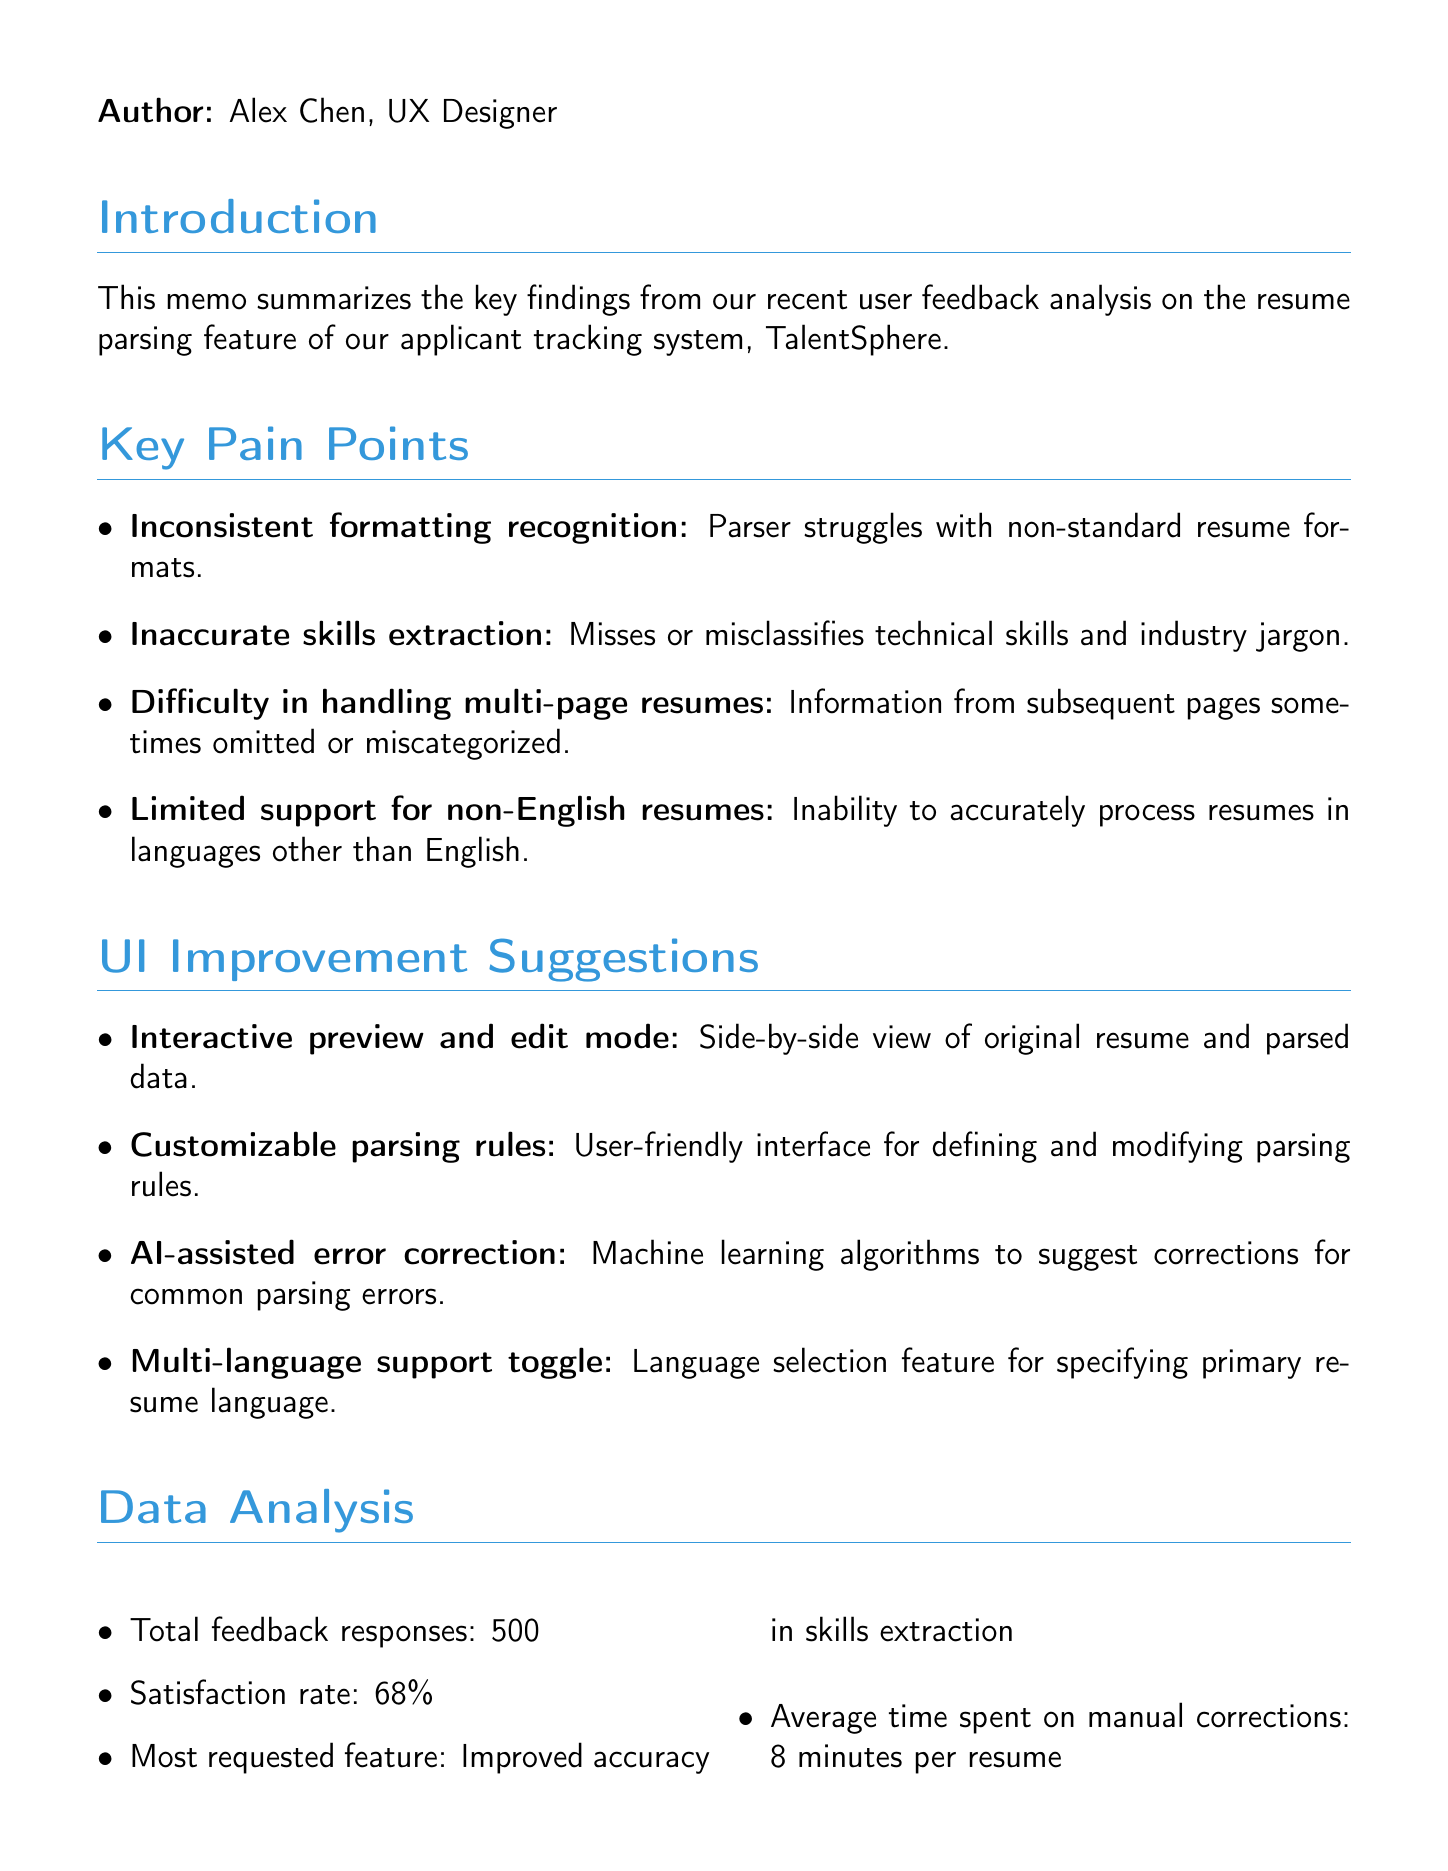what is the date of the memo? The date mentioned in the memo is May 15, 2023.
Answer: May 15, 2023 who is the author of the memo? The author of the memo is stated as Alex Chen, UX Designer.
Answer: Alex Chen, UX Designer what is the satisfaction rate reported in the feedback analysis? The satisfaction rate provided in the analysis is 68%.
Answer: 68% what is the most requested feature by users? The most requested feature outlined in the memo is improved accuracy in skills extraction.
Answer: Improved accuracy in skills extraction name one key pain point mentioned in the memo. A key pain point mentioned is the parser’s struggle with non-standard resume formats.
Answer: Inconsistent formatting recognition how many feedback responses were collected? The total number of feedback responses collected is noted as 500.
Answer: 500 what is one suggested UI improvement in the memo? One suggested UI improvement is an interactive preview and edit mode.
Answer: Interactive preview and edit mode which language support issue is highlighted in the memo? The issue highlighted is the limited support for non-English resumes.
Answer: Limited support for non-English resumes what are the next steps mentioned in the memo? The next steps in the memo include prioritizing improvement areas based on user impact.
Answer: Prioritize improvement areas based on user impact 